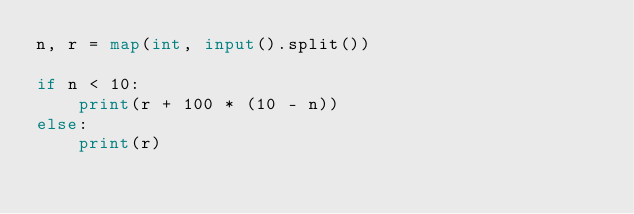Convert code to text. <code><loc_0><loc_0><loc_500><loc_500><_Python_>n, r = map(int, input().split())

if n < 10:
    print(r + 100 * (10 - n))
else:
    print(r)</code> 